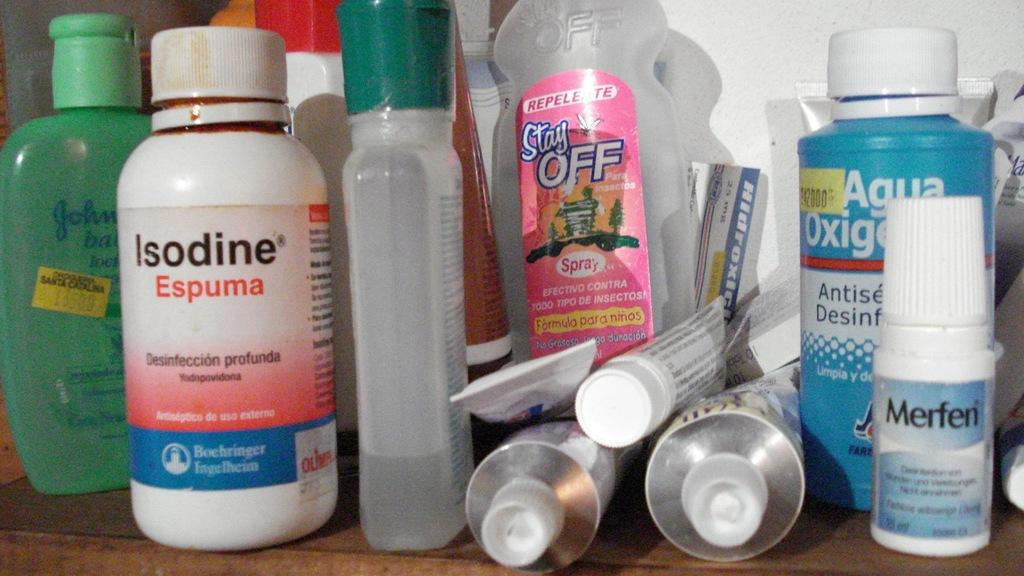<image>
Create a compact narrative representing the image presented. A bunch of first aid supplies including Isodine. 